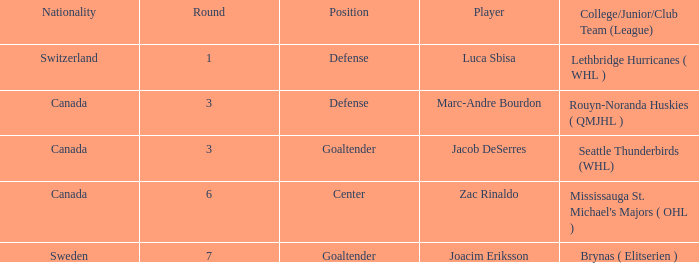What position did Luca Sbisa play for the Philadelphia Flyers? Defense. 